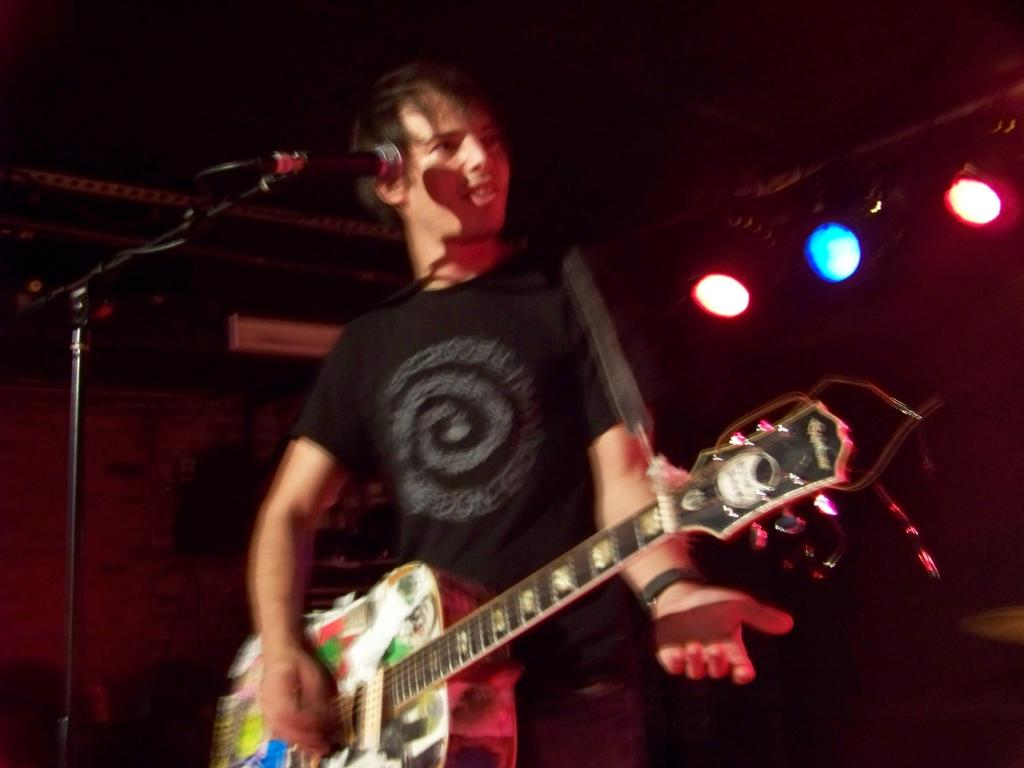Who or what is the main subject in the image? There is a person in the image. What is the person doing in the image? The person is in front of a microphone and holding a guitar. What can be seen in the background of the image? There are lights visible in the background of the image. What type of bells can be heard ringing in the image? There are no bells present in the image, and therefore no sound can be heard. What part of the person's body is visible in the image? The provided facts do not specify which part of the person's body is visible in the image. 